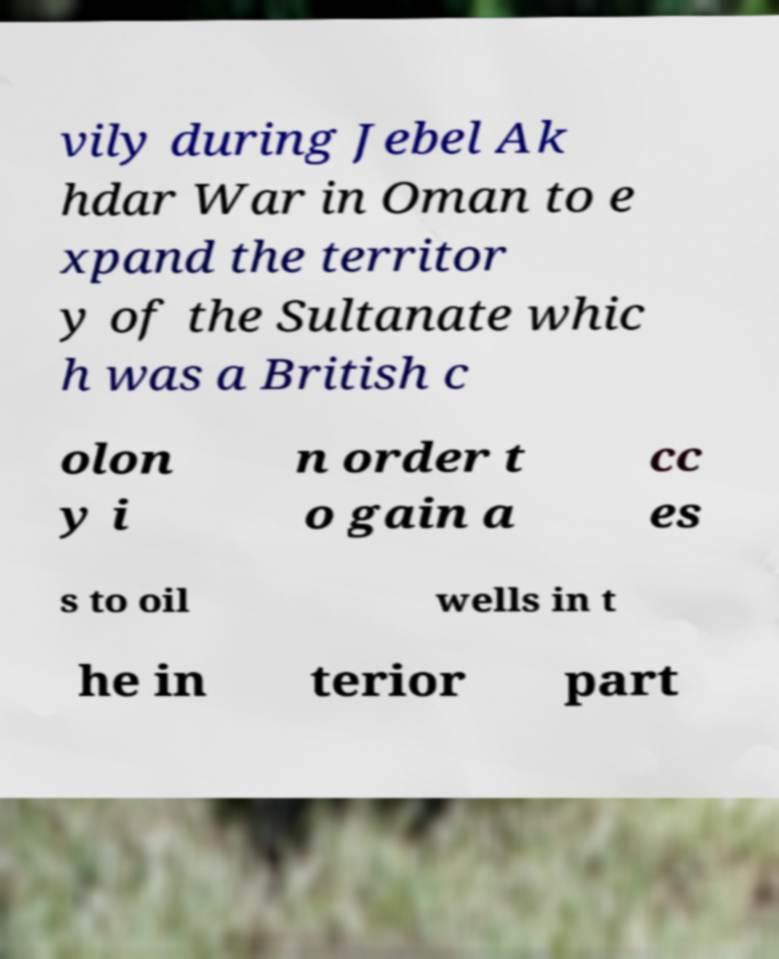I need the written content from this picture converted into text. Can you do that? vily during Jebel Ak hdar War in Oman to e xpand the territor y of the Sultanate whic h was a British c olon y i n order t o gain a cc es s to oil wells in t he in terior part 